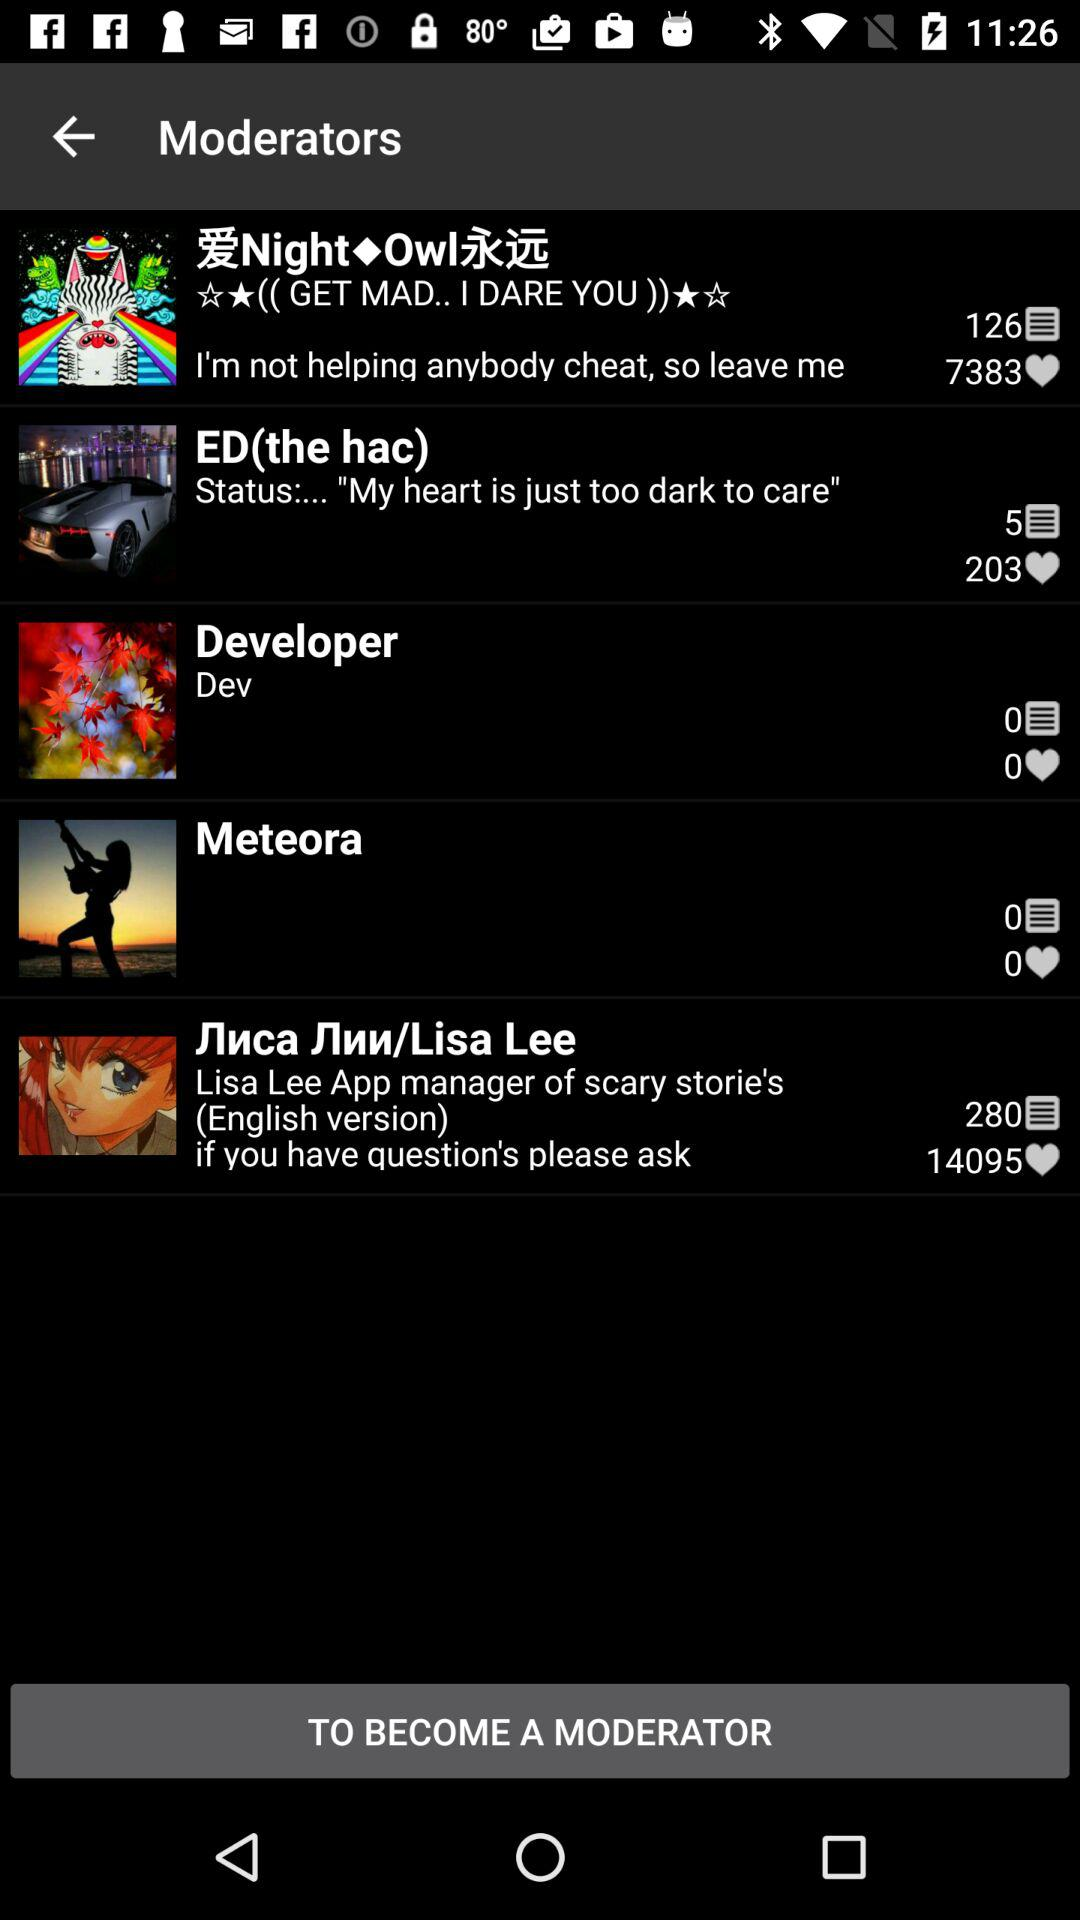How many comments are for Lisa Lee? There are 280 comments. 